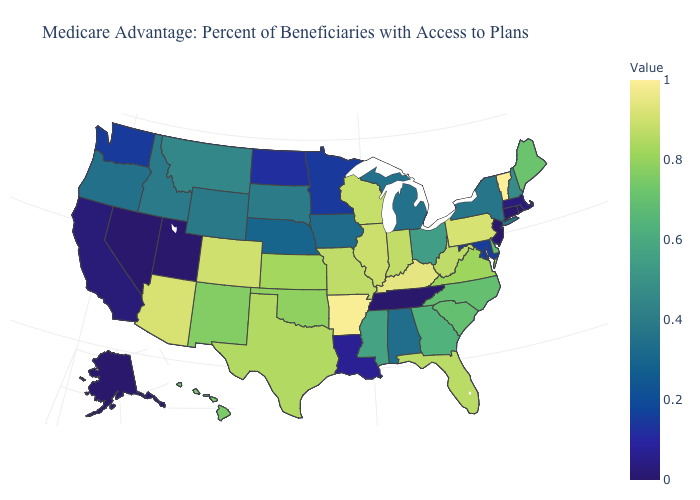Which states have the lowest value in the USA?
Answer briefly. Connecticut, New Jersey, Nevada, Rhode Island, Alaska, Tennessee, Utah. Does the map have missing data?
Be succinct. No. Which states hav the highest value in the Northeast?
Concise answer only. Vermont. Which states have the lowest value in the USA?
Short answer required. Connecticut, New Jersey, Nevada, Rhode Island, Alaska, Tennessee, Utah. 